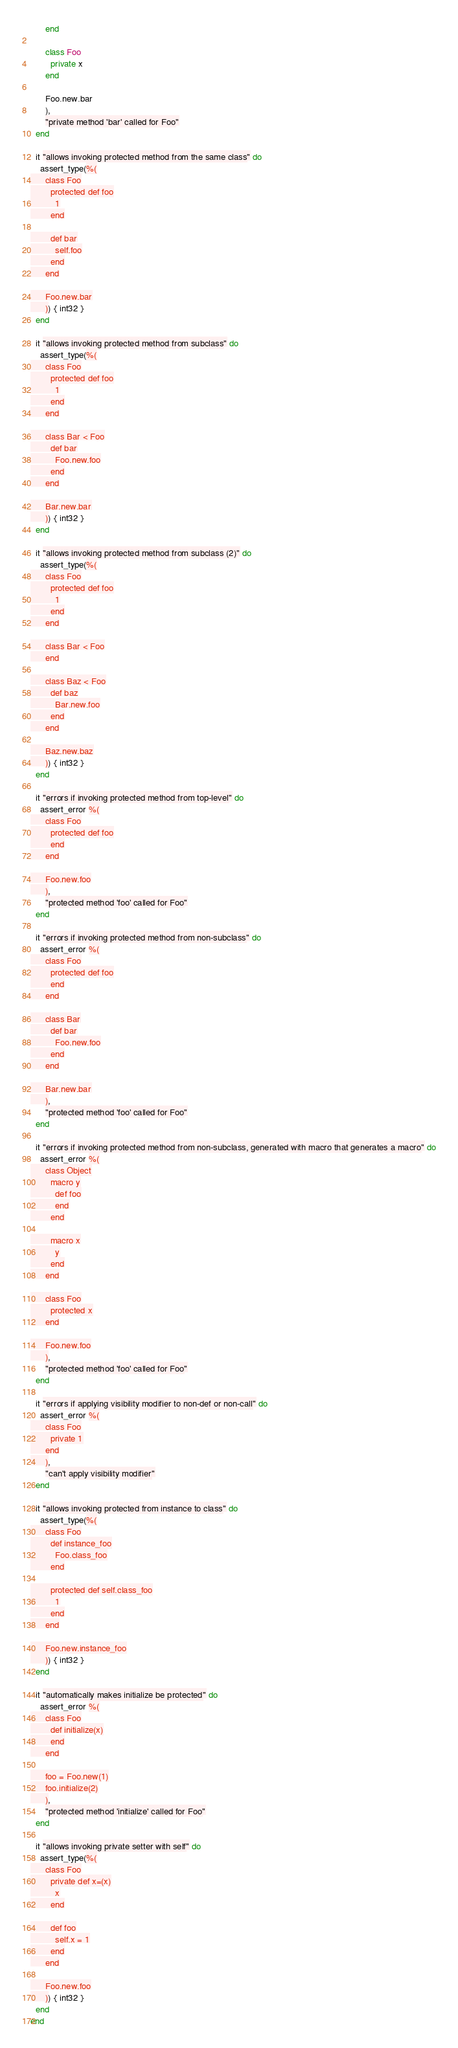<code> <loc_0><loc_0><loc_500><loc_500><_Crystal_>      end

      class Foo
        private x
      end

      Foo.new.bar
      ),
      "private method 'bar' called for Foo"
  end

  it "allows invoking protected method from the same class" do
    assert_type(%(
      class Foo
        protected def foo
          1
        end

        def bar
          self.foo
        end
      end

      Foo.new.bar
      )) { int32 }
  end

  it "allows invoking protected method from subclass" do
    assert_type(%(
      class Foo
        protected def foo
          1
        end
      end

      class Bar < Foo
        def bar
          Foo.new.foo
        end
      end

      Bar.new.bar
      )) { int32 }
  end

  it "allows invoking protected method from subclass (2)" do
    assert_type(%(
      class Foo
        protected def foo
          1
        end
      end

      class Bar < Foo
      end

      class Baz < Foo
        def baz
          Bar.new.foo
        end
      end

      Baz.new.baz
      )) { int32 }
  end

  it "errors if invoking protected method from top-level" do
    assert_error %(
      class Foo
        protected def foo
        end
      end

      Foo.new.foo
      ),
      "protected method 'foo' called for Foo"
  end

  it "errors if invoking protected method from non-subclass" do
    assert_error %(
      class Foo
        protected def foo
        end
      end

      class Bar
        def bar
          Foo.new.foo
        end
      end

      Bar.new.bar
      ),
      "protected method 'foo' called for Foo"
  end

  it "errors if invoking protected method from non-subclass, generated with macro that generates a macro" do
    assert_error %(
      class Object
        macro y
          def foo
          end
        end

        macro x
          y
        end
      end

      class Foo
        protected x
      end

      Foo.new.foo
      ),
      "protected method 'foo' called for Foo"
  end

  it "errors if applying visibility modifier to non-def or non-call" do
    assert_error %(
      class Foo
        private 1
      end
      ),
      "can't apply visibility modifier"
  end

  it "allows invoking protected from instance to class" do
    assert_type(%(
      class Foo
        def instance_foo
          Foo.class_foo
        end

        protected def self.class_foo
          1
        end
      end

      Foo.new.instance_foo
      )) { int32 }
  end

  it "automatically makes initialize be protected" do
    assert_error %(
      class Foo
        def initialize(x)
        end
      end

      foo = Foo.new(1)
      foo.initialize(2)
      ),
      "protected method 'initialize' called for Foo"
  end

  it "allows invoking private setter with self" do
    assert_type(%(
      class Foo
        private def x=(x)
          x
        end

        def foo
          self.x = 1
        end
      end

      Foo.new.foo
      )) { int32 }
  end
end
</code> 